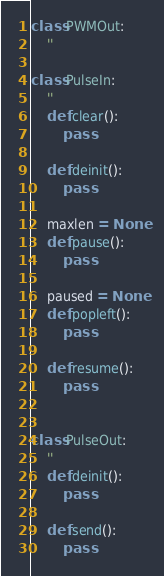Convert code to text. <code><loc_0><loc_0><loc_500><loc_500><_Python_>
class PWMOut:
    ''

class PulseIn:
    ''
    def clear():
        pass

    def deinit():
        pass

    maxlen = None
    def pause():
        pass

    paused = None
    def popleft():
        pass

    def resume():
        pass


class PulseOut:
    ''
    def deinit():
        pass

    def send():
        pass

</code> 